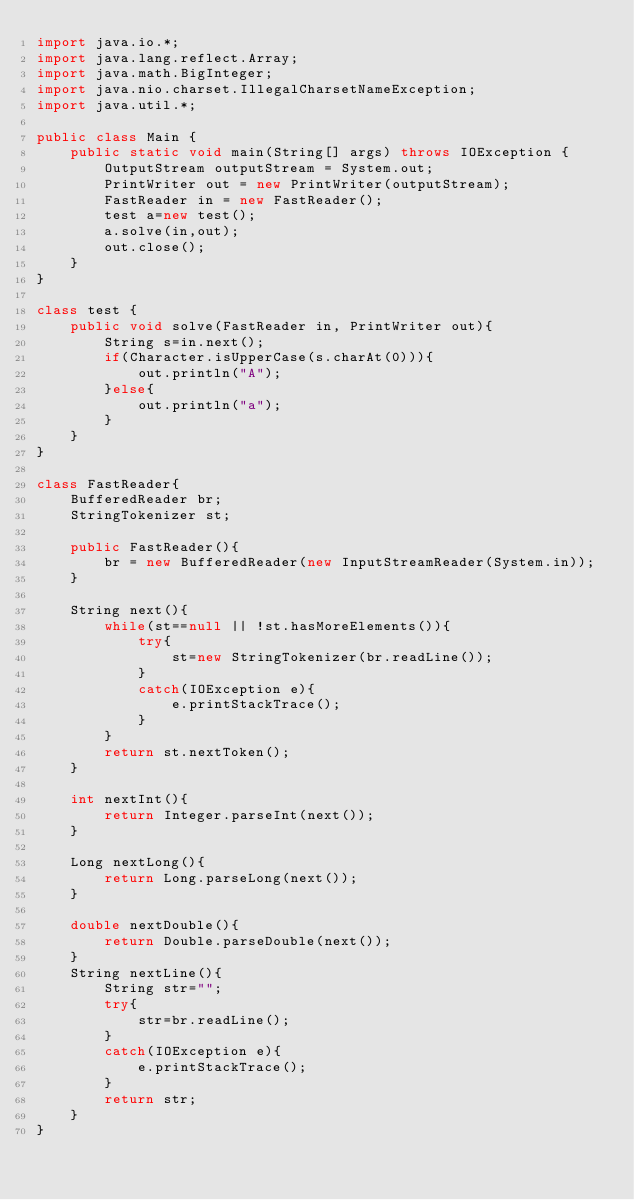<code> <loc_0><loc_0><loc_500><loc_500><_Java_>import java.io.*;
import java.lang.reflect.Array;
import java.math.BigInteger;
import java.nio.charset.IllegalCharsetNameException;
import java.util.*;

public class Main {
    public static void main(String[] args) throws IOException {
        OutputStream outputStream = System.out;
        PrintWriter out = new PrintWriter(outputStream);
        FastReader in = new FastReader();
        test a=new test();
        a.solve(in,out);
        out.close();
    }
}

class test {
    public void solve(FastReader in, PrintWriter out){
        String s=in.next();
        if(Character.isUpperCase(s.charAt(0))){
            out.println("A");
        }else{
            out.println("a");
        }
    }
}

class FastReader{
    BufferedReader br;
    StringTokenizer st;

    public FastReader(){
        br = new BufferedReader(new InputStreamReader(System.in));
    }

    String next(){
        while(st==null || !st.hasMoreElements()){
            try{
                st=new StringTokenizer(br.readLine());
            }
            catch(IOException e){
                e.printStackTrace();
            }
        }
        return st.nextToken();
    }

    int nextInt(){
        return Integer.parseInt(next());
    }

    Long nextLong(){
        return Long.parseLong(next());
    }

    double nextDouble(){
        return Double.parseDouble(next());
    }
    String nextLine(){
        String str="";
        try{
            str=br.readLine();
        }
        catch(IOException e){
            e.printStackTrace();
        }
        return str;
    }
}</code> 